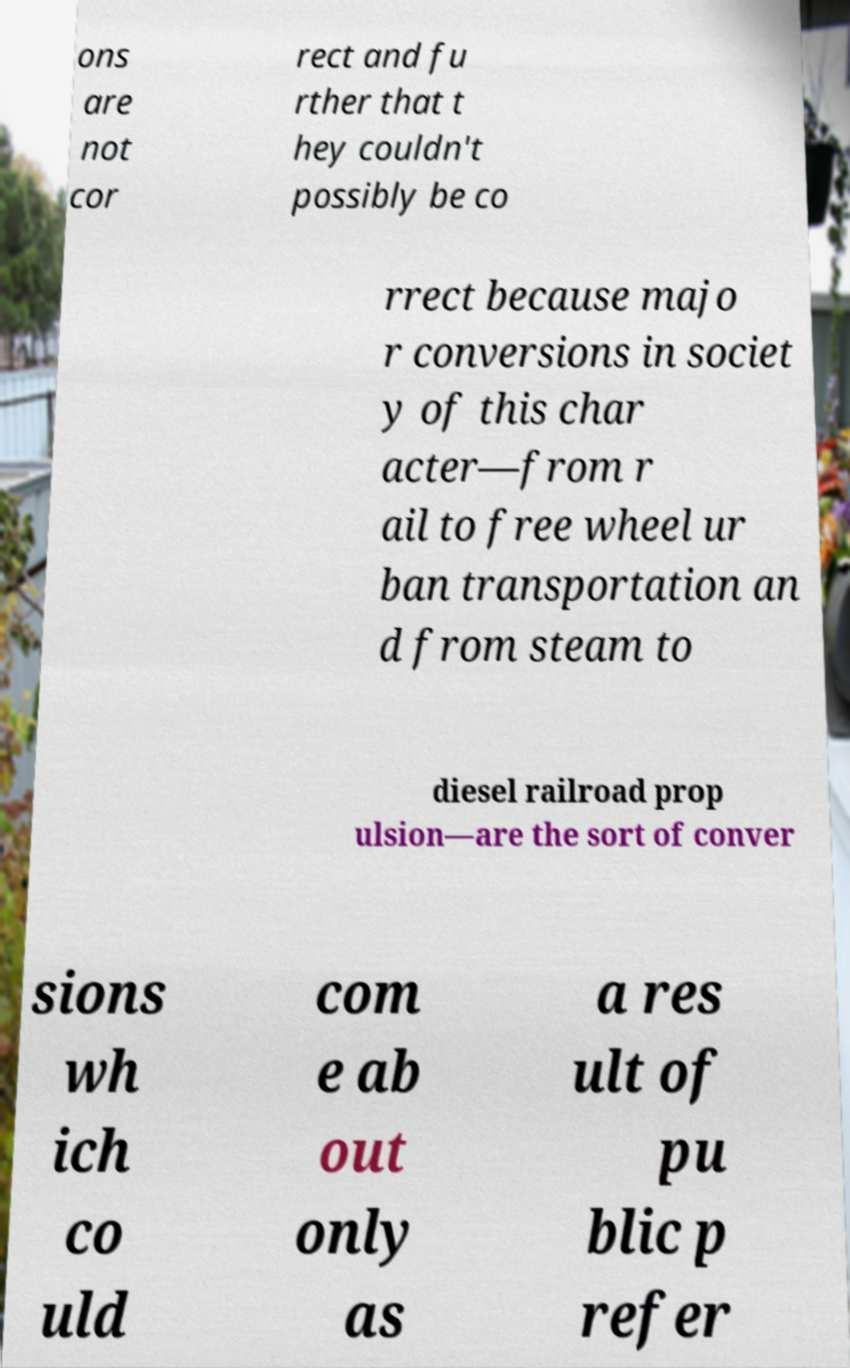For documentation purposes, I need the text within this image transcribed. Could you provide that? ons are not cor rect and fu rther that t hey couldn't possibly be co rrect because majo r conversions in societ y of this char acter—from r ail to free wheel ur ban transportation an d from steam to diesel railroad prop ulsion—are the sort of conver sions wh ich co uld com e ab out only as a res ult of pu blic p refer 